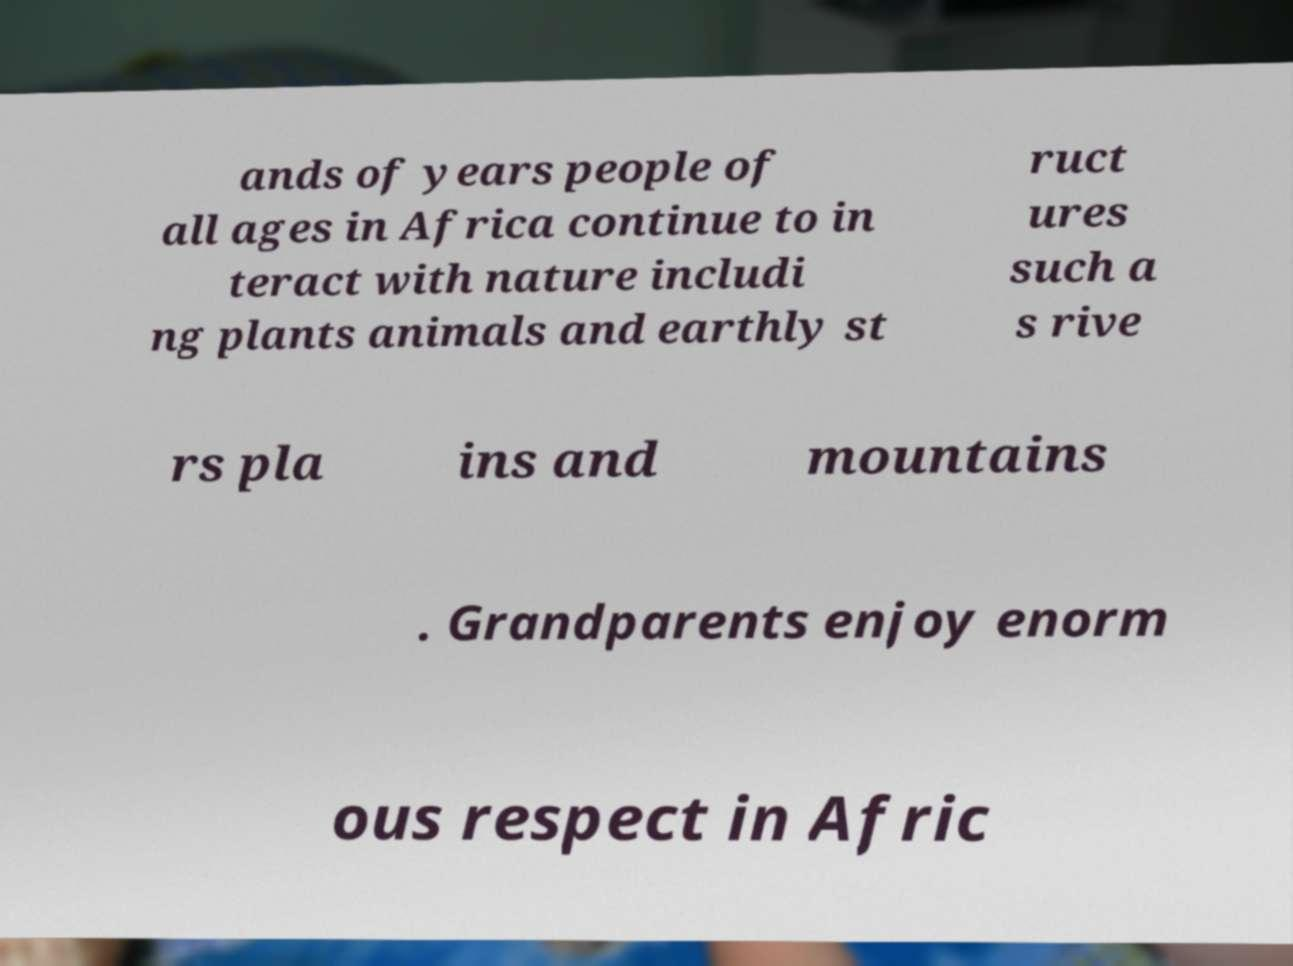Please identify and transcribe the text found in this image. ands of years people of all ages in Africa continue to in teract with nature includi ng plants animals and earthly st ruct ures such a s rive rs pla ins and mountains . Grandparents enjoy enorm ous respect in Afric 